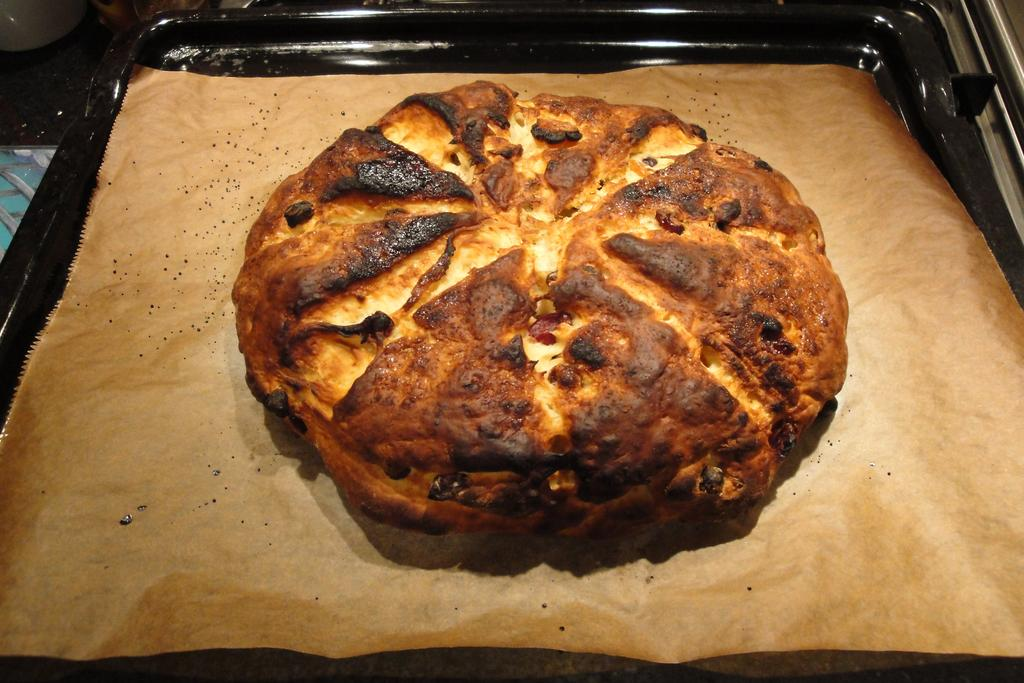What type of food can be seen in the image? There is burnt bread in the image. Where is the burnt bread located? The burnt bread is in a plate. What type of pickle is being served with the burnt bread in the image? There is no pickle present in the image; it only features burnt bread in a plate. 